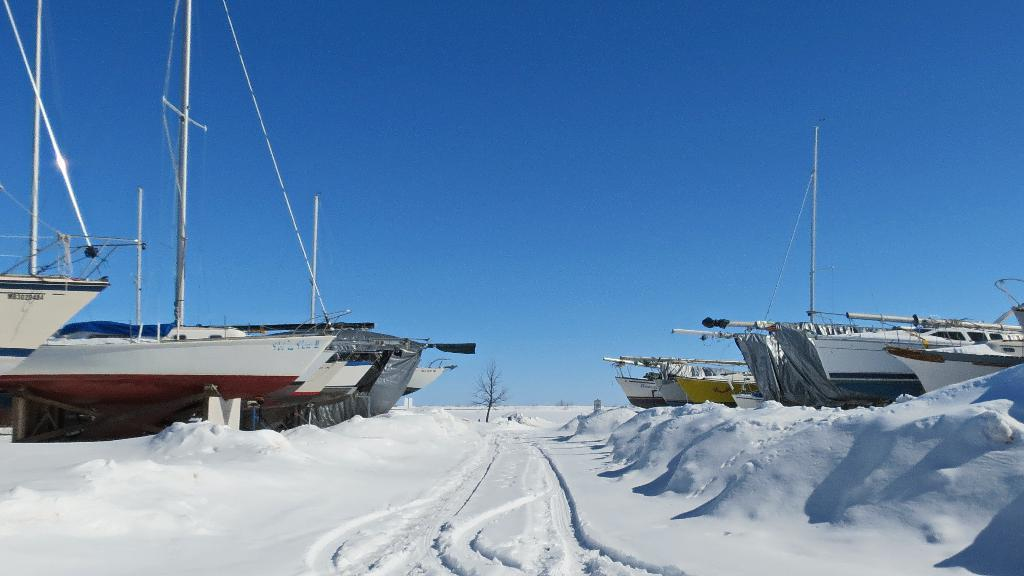What type of vehicles can be seen in the image? There are boats in the image. What structures are present in the image? Poles are present in the image. What are the boats connected to in the image? Ropes are visible in the image, connecting the boats to the poles. What is the color of the snow in the image? The snow in the image is white in color. What type of plant is in the image? There is a tree in the image. What color is the sky in the image? The sky is blue in the image. What shape is the bear in the image? There is no bear present in the image. Are the fairies flying around the tree in the image? There are no fairies present in the image. 